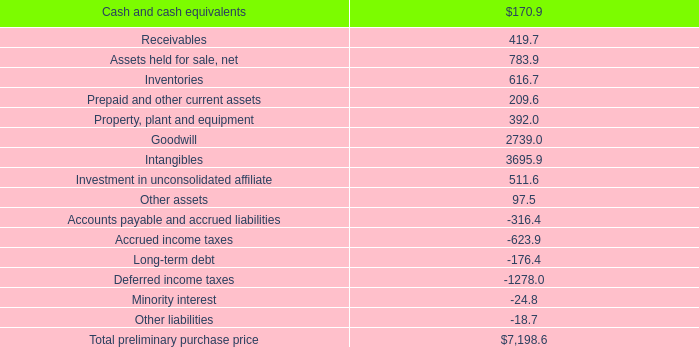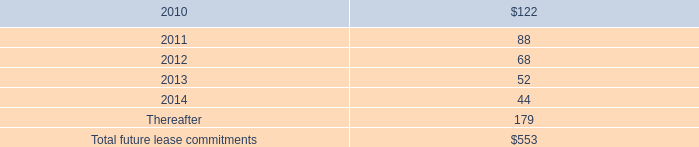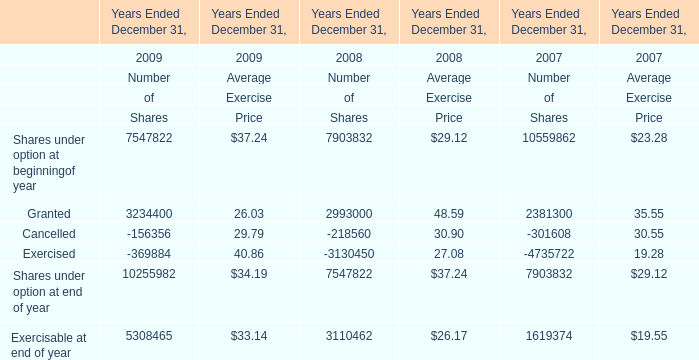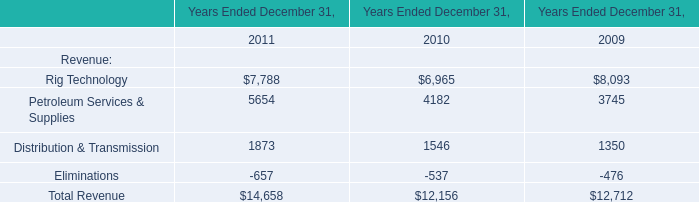What is the average amount of Rig Technology of Years Ended December 31, 2009, and Cancelled of Years Ended December 31, 2007 Number of Shares ? 
Computations: ((8093.0 + 301608.0) / 2)
Answer: 154850.5. 